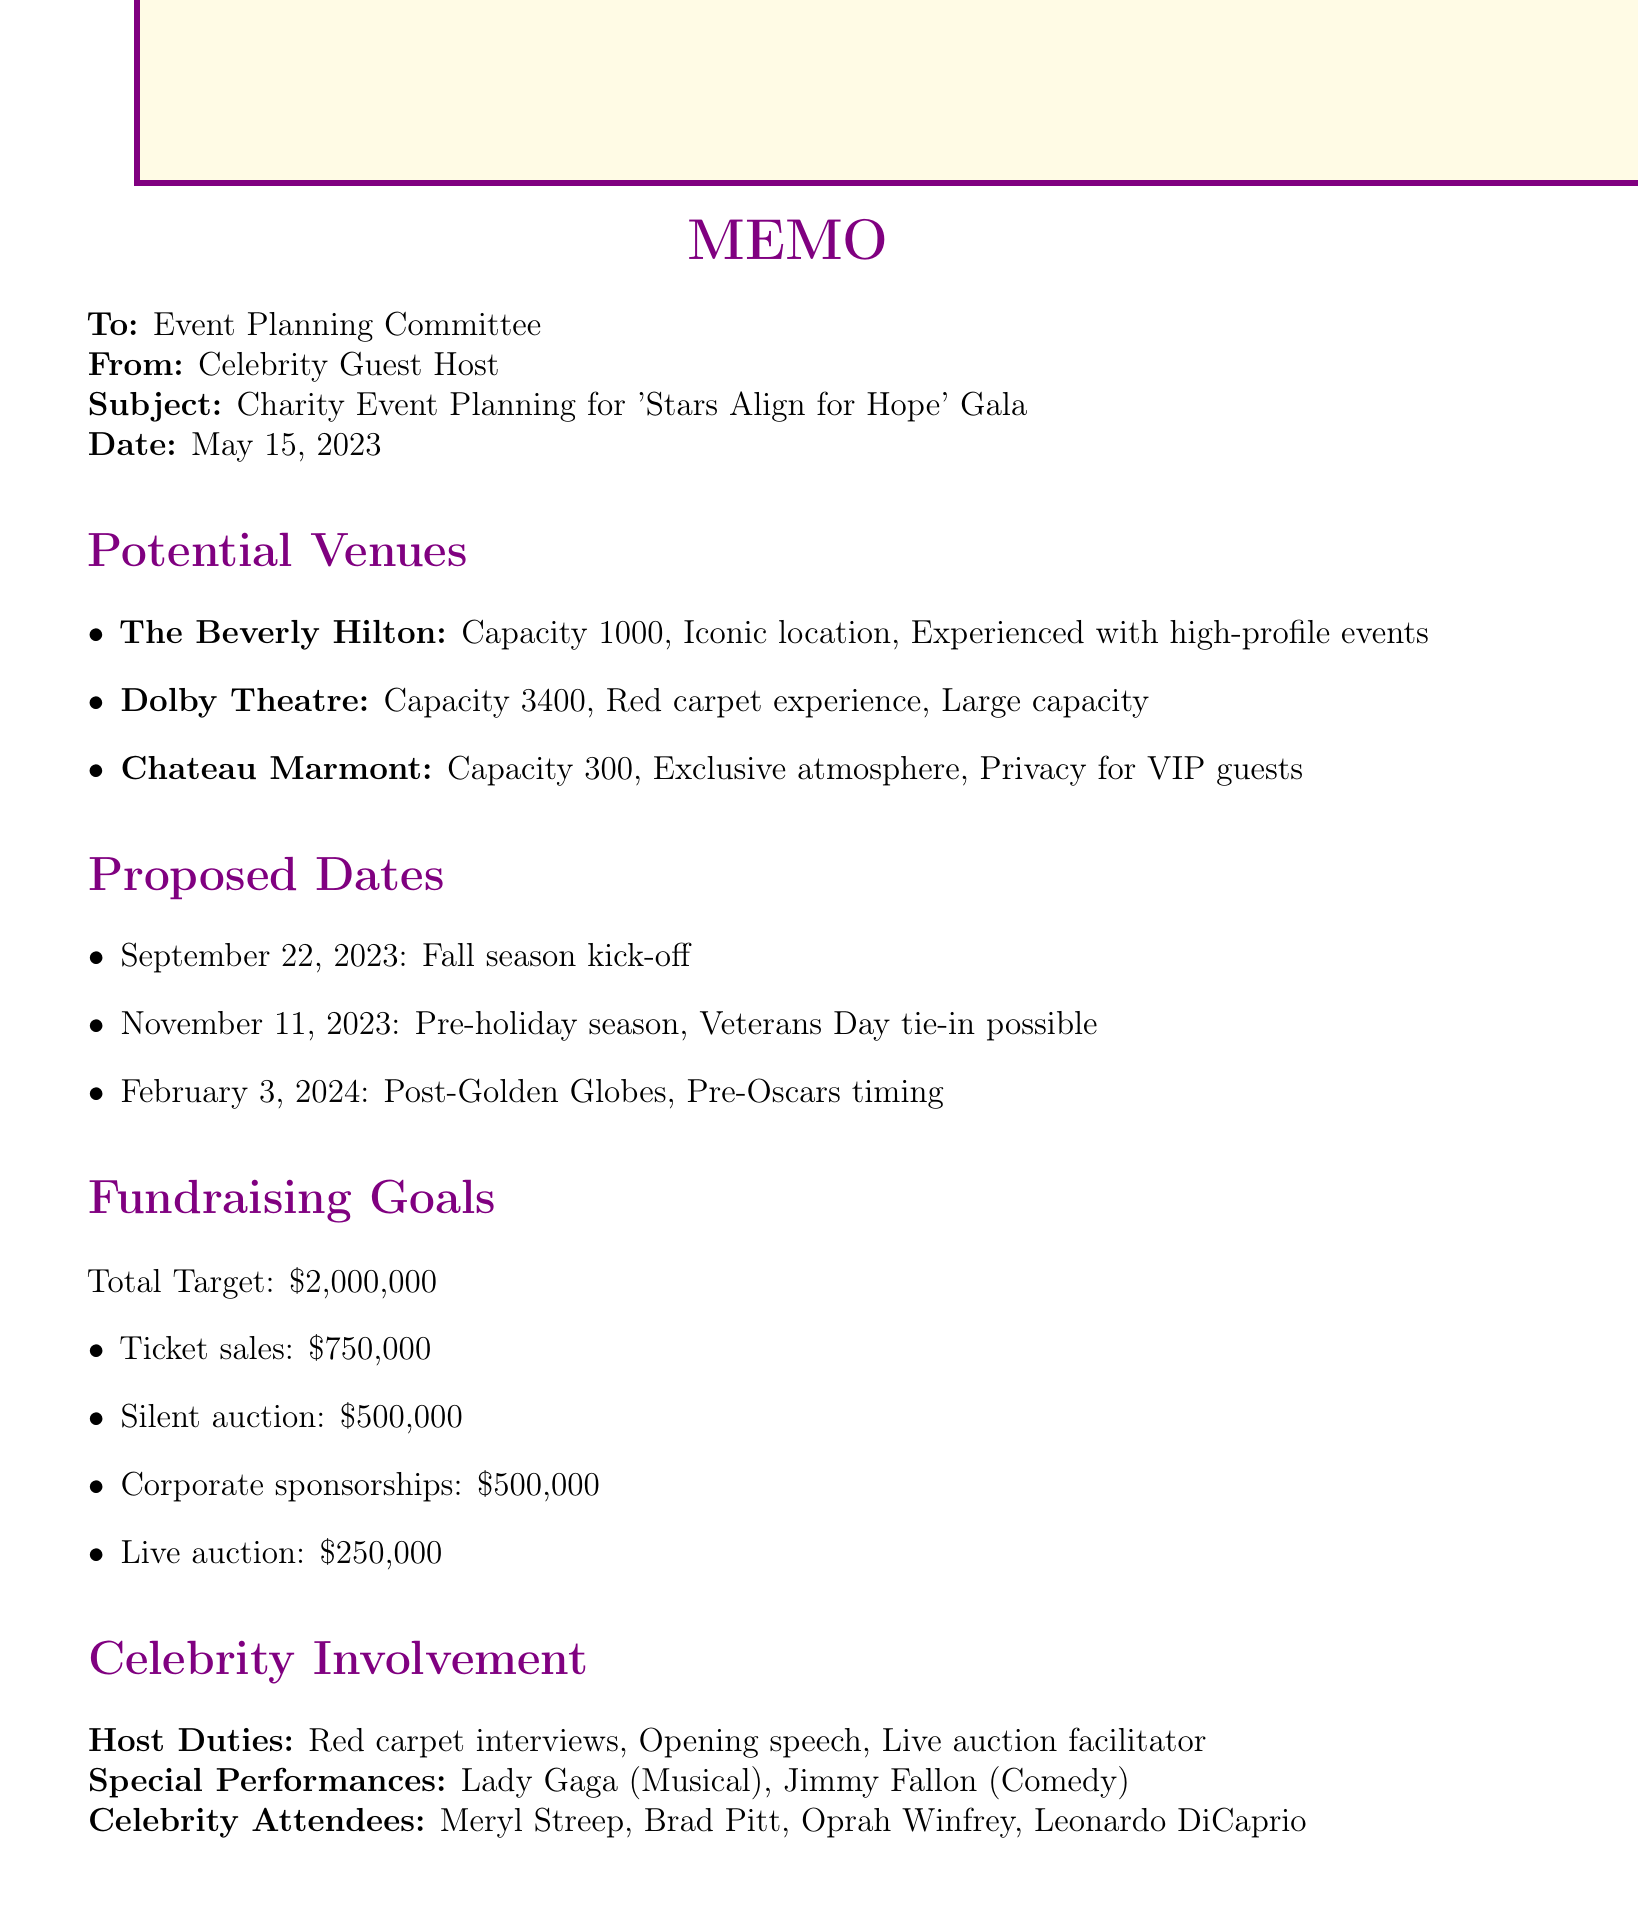What is the total fundraising goal? The total fundraising goal is clearly stated in the document as $2,000,000.
Answer: $2,000,000 What is the capacity of The Beverly Hilton? The document lists the capacity of The Beverly Hilton as 1000.
Answer: 1000 What is a proposed date for the charity event? The memo includes several proposed dates; one example is September 22, 2023.
Answer: September 22, 2023 Who are some celebrity attendees mentioned? The document lists several celebrities; for instance, Meryl Streep is included among the attendees.
Answer: Meryl Streep What are the pros of having the event at Chateau Marmont? The pros specified for Chateau Marmont include an exclusive atmosphere and privacy for VIP guests.
Answer: Exclusive atmosphere, privacy for VIP guests What are key talking points for the cause spotlight? The key talking points include the importance of education in developing countries and success stories from the previous year's funding.
Answer: Importance of education, success stories What type of special performance is scheduled? The document mentions a musical performance by Lady Gaga as one of the special performances.
Answer: Musical performance What is a unique element of the charity event? The memo highlights a live streaming option for global audience participation as a unique element of the event.
Answer: Live streaming option What is the goal for ticket sales? The document specifically states that the goal for ticket sales is $750,000.
Answer: $750,000 